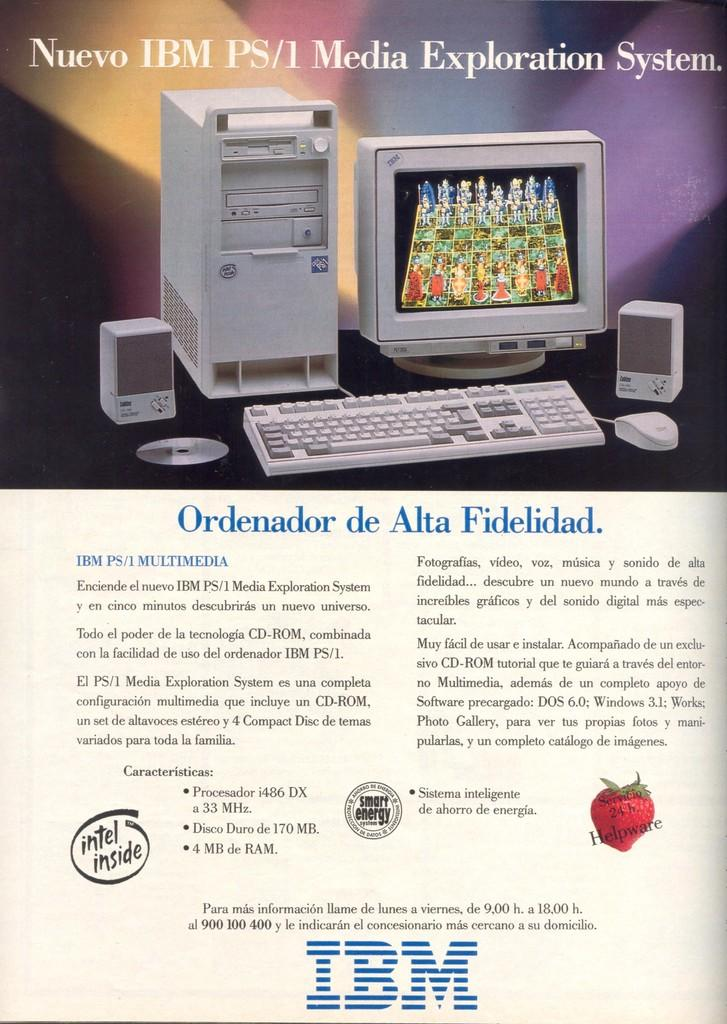<image>
Describe the image concisely. An advertisement for an IBM desktop in a language other than English. 